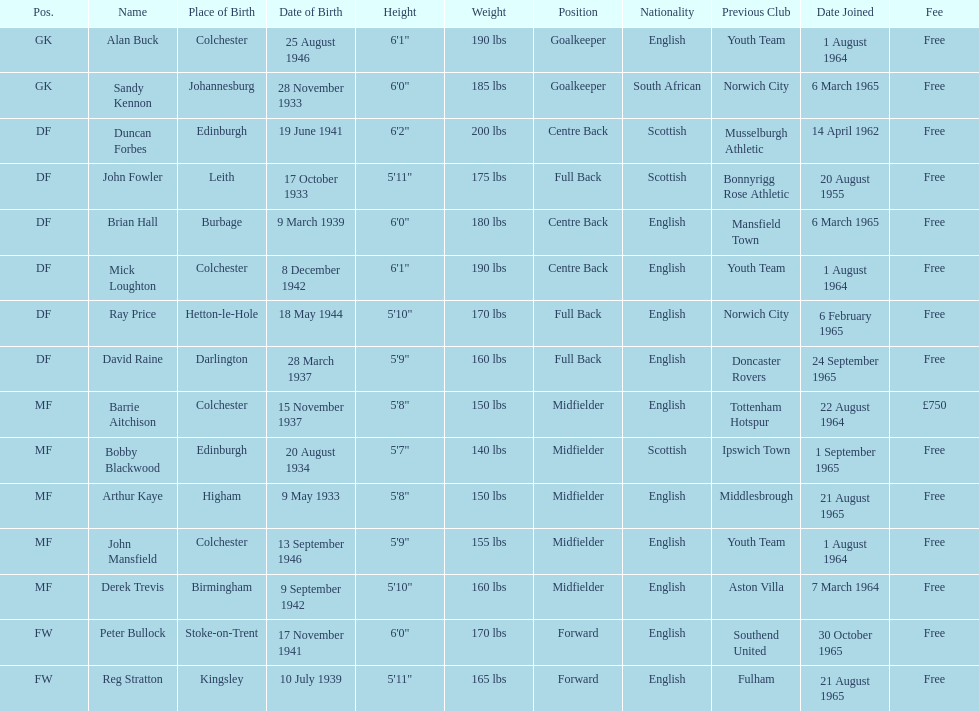What is the other fee listed, besides free? £750. 